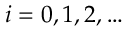<formula> <loc_0><loc_0><loc_500><loc_500>i = 0 , 1 , 2 , \dots</formula> 